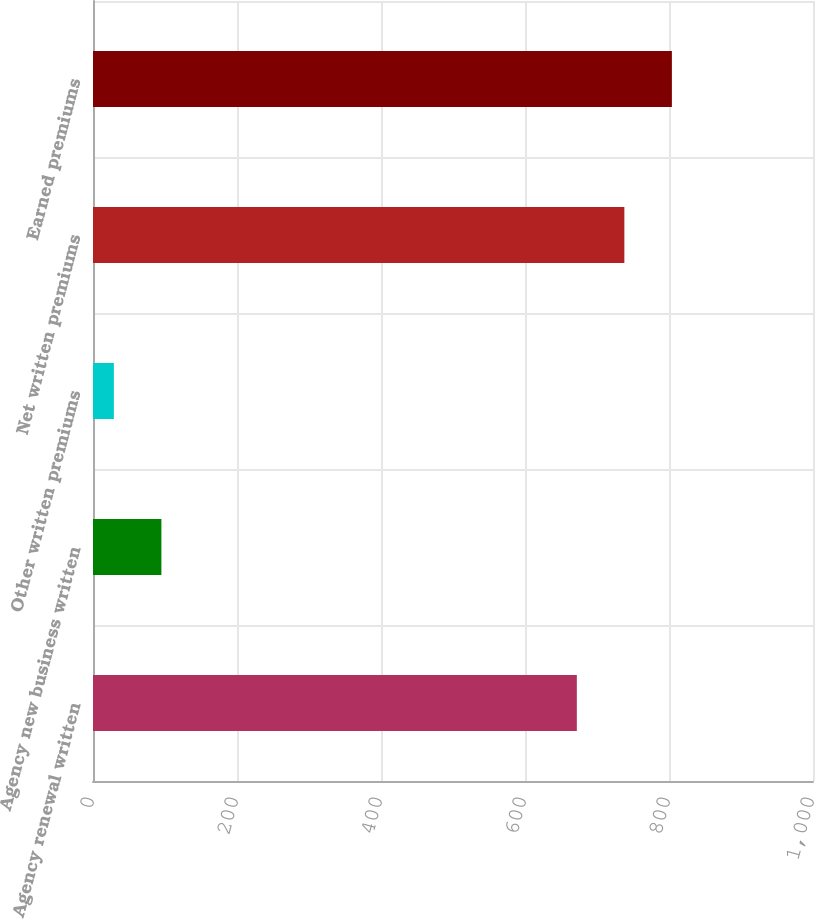Convert chart. <chart><loc_0><loc_0><loc_500><loc_500><bar_chart><fcel>Agency renewal written<fcel>Agency new business written<fcel>Other written premiums<fcel>Net written premiums<fcel>Earned premiums<nl><fcel>672<fcel>95<fcel>29<fcel>738<fcel>804<nl></chart> 